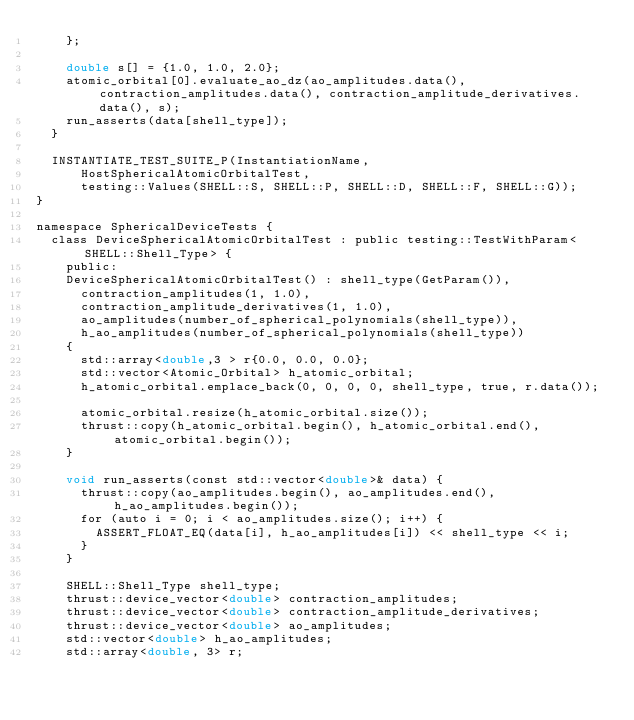<code> <loc_0><loc_0><loc_500><loc_500><_Cuda_>    };

    double s[] = {1.0, 1.0, 2.0};
    atomic_orbital[0].evaluate_ao_dz(ao_amplitudes.data(), contraction_amplitudes.data(), contraction_amplitude_derivatives.data(), s);
    run_asserts(data[shell_type]);
  }

  INSTANTIATE_TEST_SUITE_P(InstantiationName,
      HostSphericalAtomicOrbitalTest,
      testing::Values(SHELL::S, SHELL::P, SHELL::D, SHELL::F, SHELL::G));
}

namespace SphericalDeviceTests {
  class DeviceSphericalAtomicOrbitalTest : public testing::TestWithParam<SHELL::Shell_Type> {
    public:
    DeviceSphericalAtomicOrbitalTest() : shell_type(GetParam()), 
      contraction_amplitudes(1, 1.0),
      contraction_amplitude_derivatives(1, 1.0),
      ao_amplitudes(number_of_spherical_polynomials(shell_type)),
      h_ao_amplitudes(number_of_spherical_polynomials(shell_type))
    { 
      std::array<double,3 > r{0.0, 0.0, 0.0};
      std::vector<Atomic_Orbital> h_atomic_orbital;
      h_atomic_orbital.emplace_back(0, 0, 0, 0, shell_type, true, r.data());

      atomic_orbital.resize(h_atomic_orbital.size());
      thrust::copy(h_atomic_orbital.begin(), h_atomic_orbital.end(), atomic_orbital.begin());
    }

    void run_asserts(const std::vector<double>& data) {
      thrust::copy(ao_amplitudes.begin(), ao_amplitudes.end(), h_ao_amplitudes.begin());
      for (auto i = 0; i < ao_amplitudes.size(); i++) {
        ASSERT_FLOAT_EQ(data[i], h_ao_amplitudes[i]) << shell_type << i;
      }
    }

    SHELL::Shell_Type shell_type;
    thrust::device_vector<double> contraction_amplitudes;
    thrust::device_vector<double> contraction_amplitude_derivatives;
    thrust::device_vector<double> ao_amplitudes;
    std::vector<double> h_ao_amplitudes;
    std::array<double, 3> r;</code> 